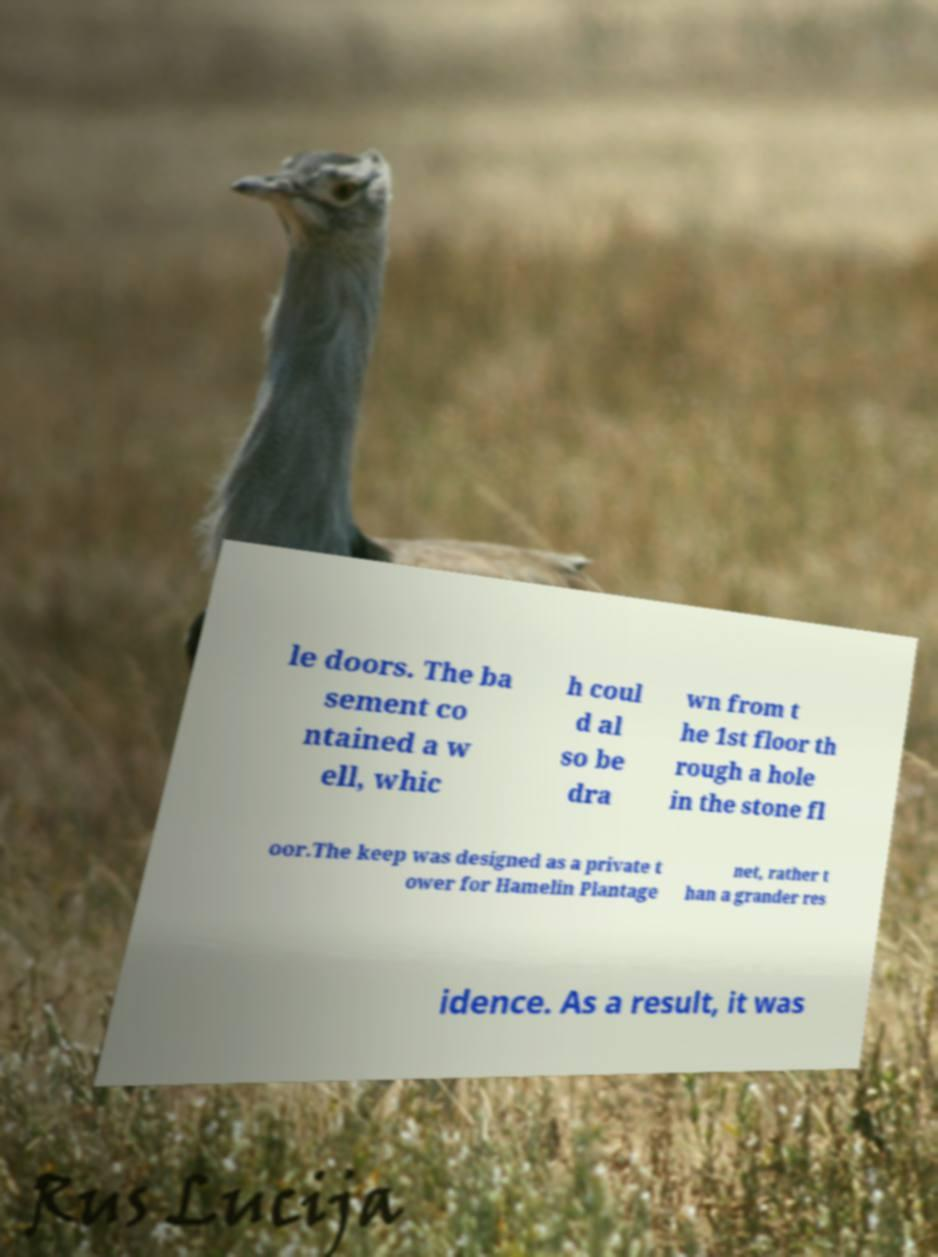There's text embedded in this image that I need extracted. Can you transcribe it verbatim? le doors. The ba sement co ntained a w ell, whic h coul d al so be dra wn from t he 1st floor th rough a hole in the stone fl oor.The keep was designed as a private t ower for Hamelin Plantage net, rather t han a grander res idence. As a result, it was 